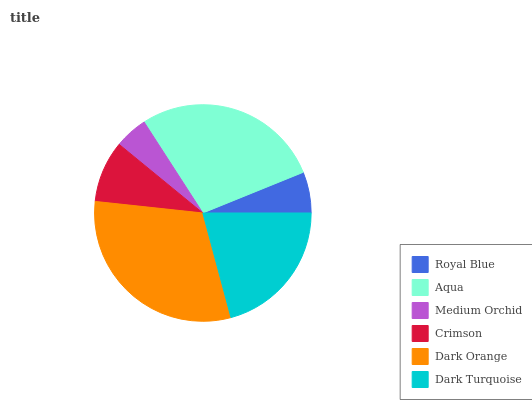Is Medium Orchid the minimum?
Answer yes or no. Yes. Is Dark Orange the maximum?
Answer yes or no. Yes. Is Aqua the minimum?
Answer yes or no. No. Is Aqua the maximum?
Answer yes or no. No. Is Aqua greater than Royal Blue?
Answer yes or no. Yes. Is Royal Blue less than Aqua?
Answer yes or no. Yes. Is Royal Blue greater than Aqua?
Answer yes or no. No. Is Aqua less than Royal Blue?
Answer yes or no. No. Is Dark Turquoise the high median?
Answer yes or no. Yes. Is Crimson the low median?
Answer yes or no. Yes. Is Dark Orange the high median?
Answer yes or no. No. Is Medium Orchid the low median?
Answer yes or no. No. 